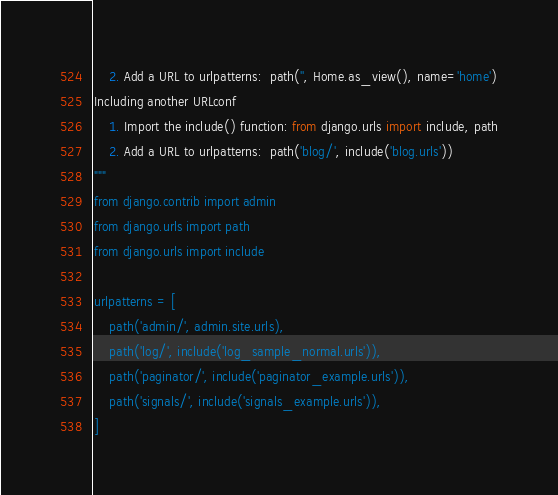<code> <loc_0><loc_0><loc_500><loc_500><_Python_>    2. Add a URL to urlpatterns:  path('', Home.as_view(), name='home')
Including another URLconf
    1. Import the include() function: from django.urls import include, path
    2. Add a URL to urlpatterns:  path('blog/', include('blog.urls'))
"""
from django.contrib import admin
from django.urls import path
from django.urls import include

urlpatterns = [
    path('admin/', admin.site.urls),
    path('log/', include('log_sample_normal.urls')),
    path('paginator/', include('paginator_example.urls')),
    path('signals/', include('signals_example.urls')),
]
</code> 